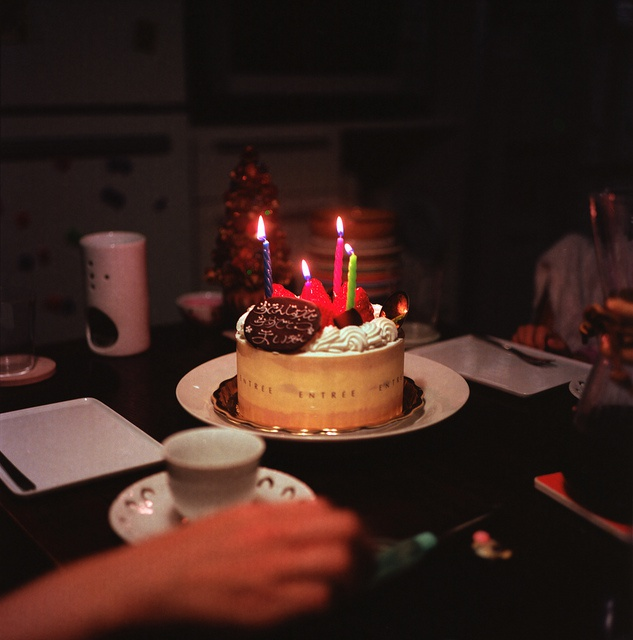Describe the objects in this image and their specific colors. I can see dining table in black, maroon, and brown tones, people in black, maroon, and brown tones, bowl in black, tan, brown, and salmon tones, cup in black, maroon, brown, and tan tones, and cup in black, brown, and maroon tones in this image. 